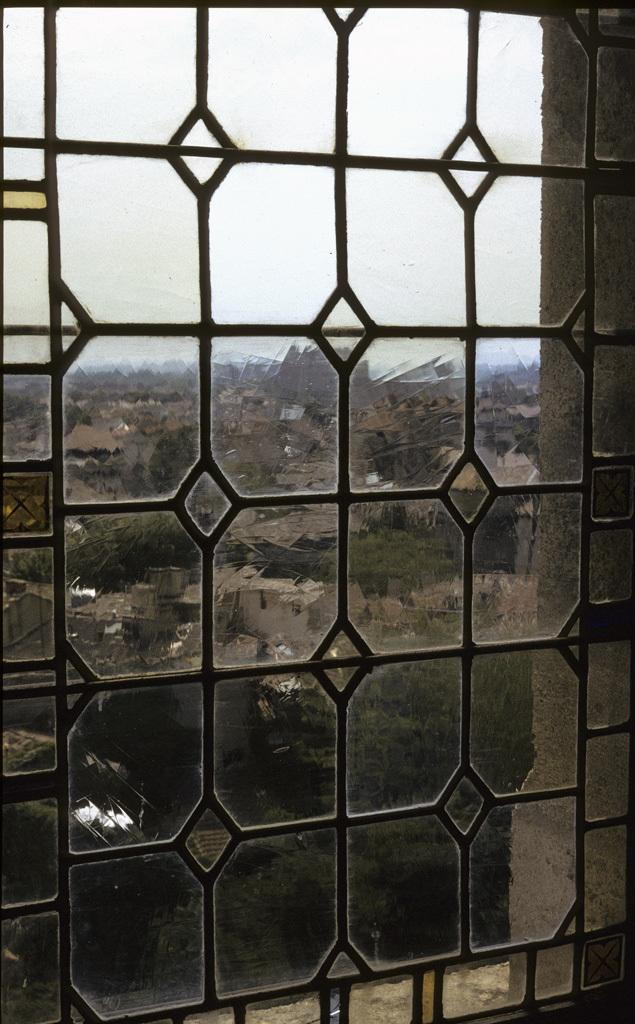What type of structures can be seen in the image? There are buildings in the image. What other natural elements are present in the image? There are trees in the image. What is visible at the top of the image? The sky is visible at the top of the image. What is located in the foreground of the image? There is a window in the foreground of the image. Can you describe the background of the image? There might be mountains in the background of the image. What shape is the steam coming out of the building in the image? There is no steam coming out of a building in the image. What type of building is depicted in the image? The provided facts do not specify the type of building; they only mention that there are buildings in the image. 